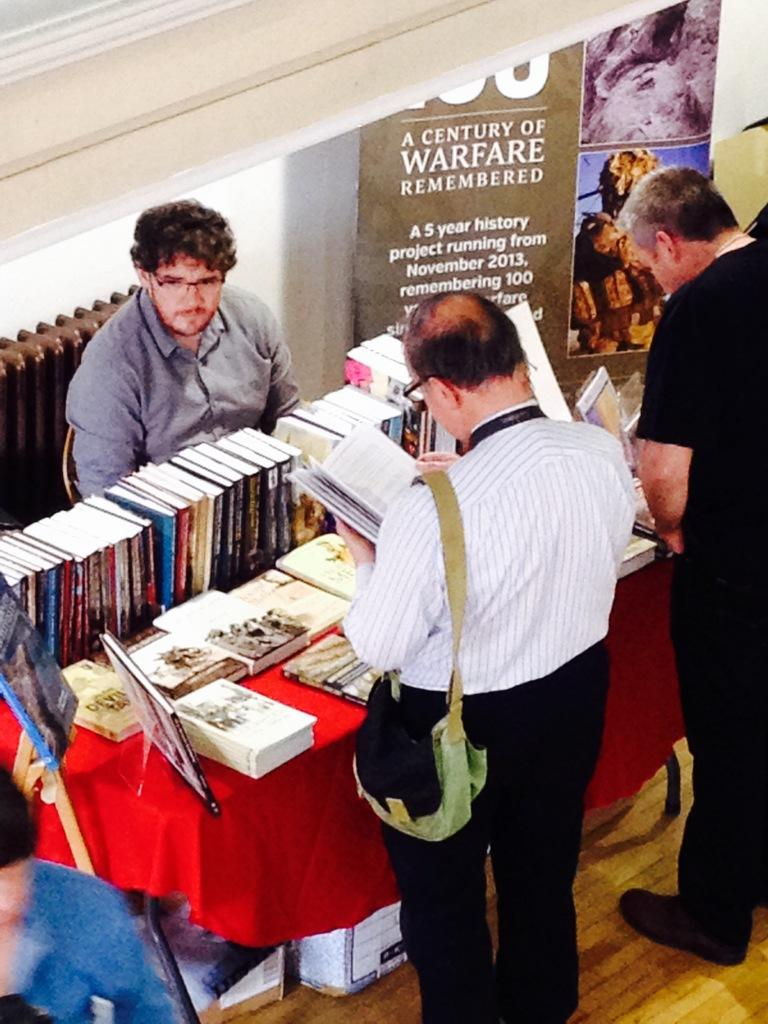<image>
Render a clear and concise summary of the photo. a series of books next to a century of warfare poster 